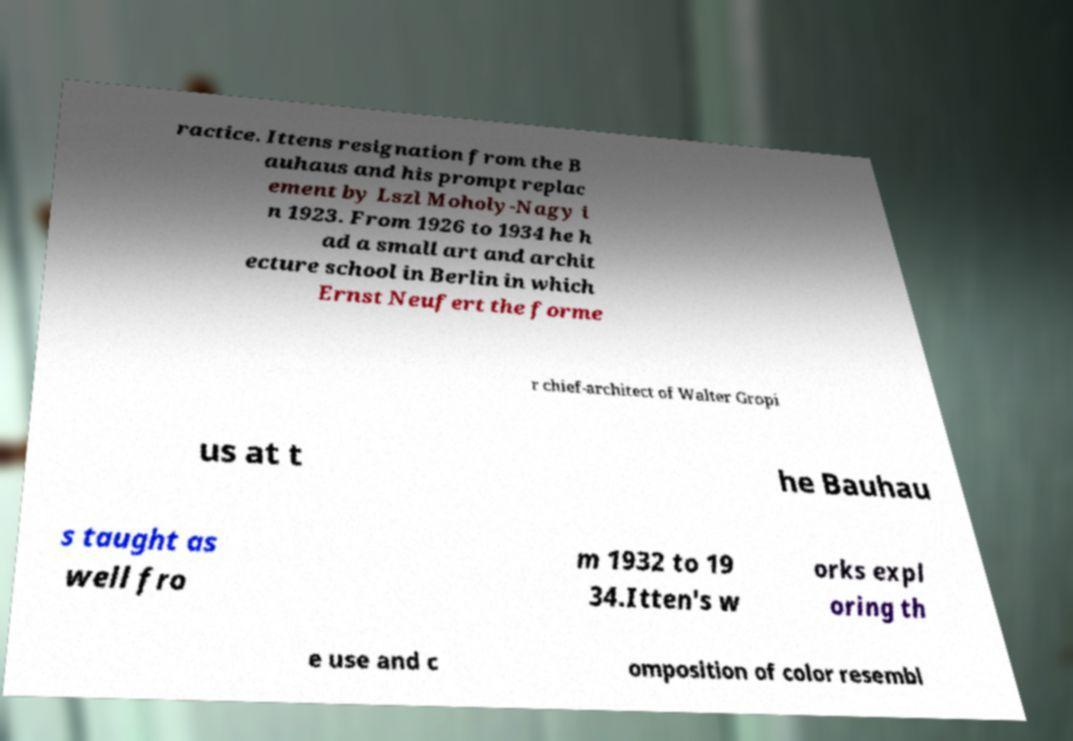Could you extract and type out the text from this image? ractice. Ittens resignation from the B auhaus and his prompt replac ement by Lszl Moholy-Nagy i n 1923. From 1926 to 1934 he h ad a small art and archit ecture school in Berlin in which Ernst Neufert the forme r chief-architect of Walter Gropi us at t he Bauhau s taught as well fro m 1932 to 19 34.Itten's w orks expl oring th e use and c omposition of color resembl 